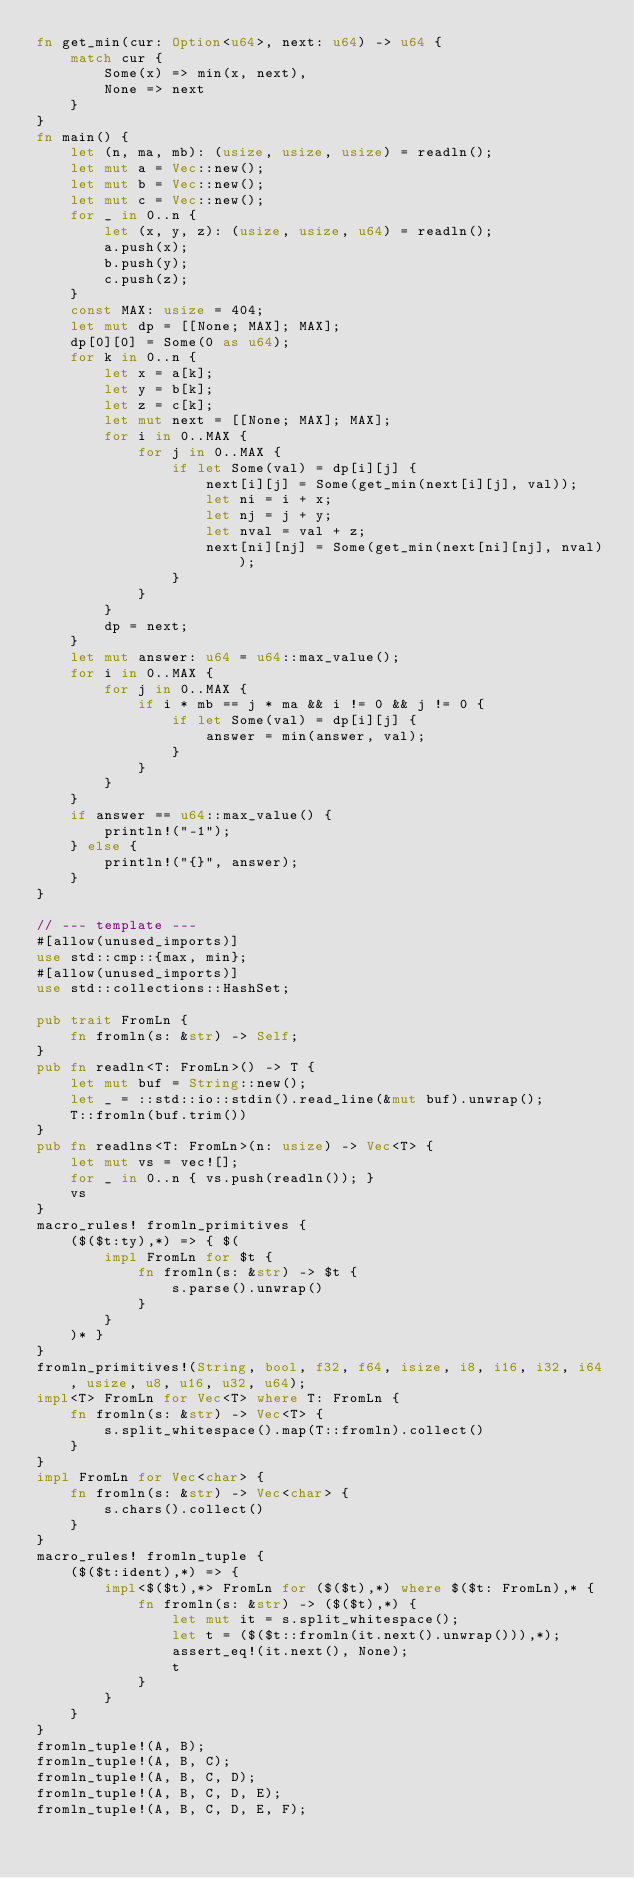Convert code to text. <code><loc_0><loc_0><loc_500><loc_500><_Rust_>fn get_min(cur: Option<u64>, next: u64) -> u64 {
    match cur {
        Some(x) => min(x, next),
        None => next
    }
}
fn main() {
    let (n, ma, mb): (usize, usize, usize) = readln();
    let mut a = Vec::new();
    let mut b = Vec::new();
    let mut c = Vec::new();
    for _ in 0..n {
        let (x, y, z): (usize, usize, u64) = readln();
        a.push(x);
        b.push(y);
        c.push(z);
    }
    const MAX: usize = 404;
    let mut dp = [[None; MAX]; MAX];
    dp[0][0] = Some(0 as u64);
    for k in 0..n {
        let x = a[k];
        let y = b[k];
        let z = c[k];
        let mut next = [[None; MAX]; MAX];
        for i in 0..MAX {
            for j in 0..MAX {
                if let Some(val) = dp[i][j] {
                    next[i][j] = Some(get_min(next[i][j], val));
                    let ni = i + x;
                    let nj = j + y;
                    let nval = val + z;
                    next[ni][nj] = Some(get_min(next[ni][nj], nval));
                }
            }
        }
        dp = next;
    }
    let mut answer: u64 = u64::max_value();
    for i in 0..MAX {
        for j in 0..MAX {
            if i * mb == j * ma && i != 0 && j != 0 {
                if let Some(val) = dp[i][j] {
                    answer = min(answer, val);
                }
            }
        }
    }
    if answer == u64::max_value() {
        println!("-1");
    } else {
        println!("{}", answer);
    }
}

// --- template ---
#[allow(unused_imports)]
use std::cmp::{max, min};
#[allow(unused_imports)]
use std::collections::HashSet;

pub trait FromLn {
    fn fromln(s: &str) -> Self;
}
pub fn readln<T: FromLn>() -> T {
    let mut buf = String::new();
    let _ = ::std::io::stdin().read_line(&mut buf).unwrap();
    T::fromln(buf.trim())
}
pub fn readlns<T: FromLn>(n: usize) -> Vec<T> {
    let mut vs = vec![];
    for _ in 0..n { vs.push(readln()); }
    vs
}
macro_rules! fromln_primitives {
    ($($t:ty),*) => { $(
        impl FromLn for $t {
            fn fromln(s: &str) -> $t {
                s.parse().unwrap()
            }
        }
    )* }
}
fromln_primitives!(String, bool, f32, f64, isize, i8, i16, i32, i64, usize, u8, u16, u32, u64);
impl<T> FromLn for Vec<T> where T: FromLn {
    fn fromln(s: &str) -> Vec<T> {
        s.split_whitespace().map(T::fromln).collect()
    }
}
impl FromLn for Vec<char> {
    fn fromln(s: &str) -> Vec<char> {
        s.chars().collect()
    }
}
macro_rules! fromln_tuple {
    ($($t:ident),*) => {
        impl<$($t),*> FromLn for ($($t),*) where $($t: FromLn),* {
            fn fromln(s: &str) -> ($($t),*) {
                let mut it = s.split_whitespace();
                let t = ($($t::fromln(it.next().unwrap())),*);
                assert_eq!(it.next(), None);
                t
            }
        }
    }
}
fromln_tuple!(A, B);
fromln_tuple!(A, B, C);
fromln_tuple!(A, B, C, D);
fromln_tuple!(A, B, C, D, E);
fromln_tuple!(A, B, C, D, E, F);</code> 